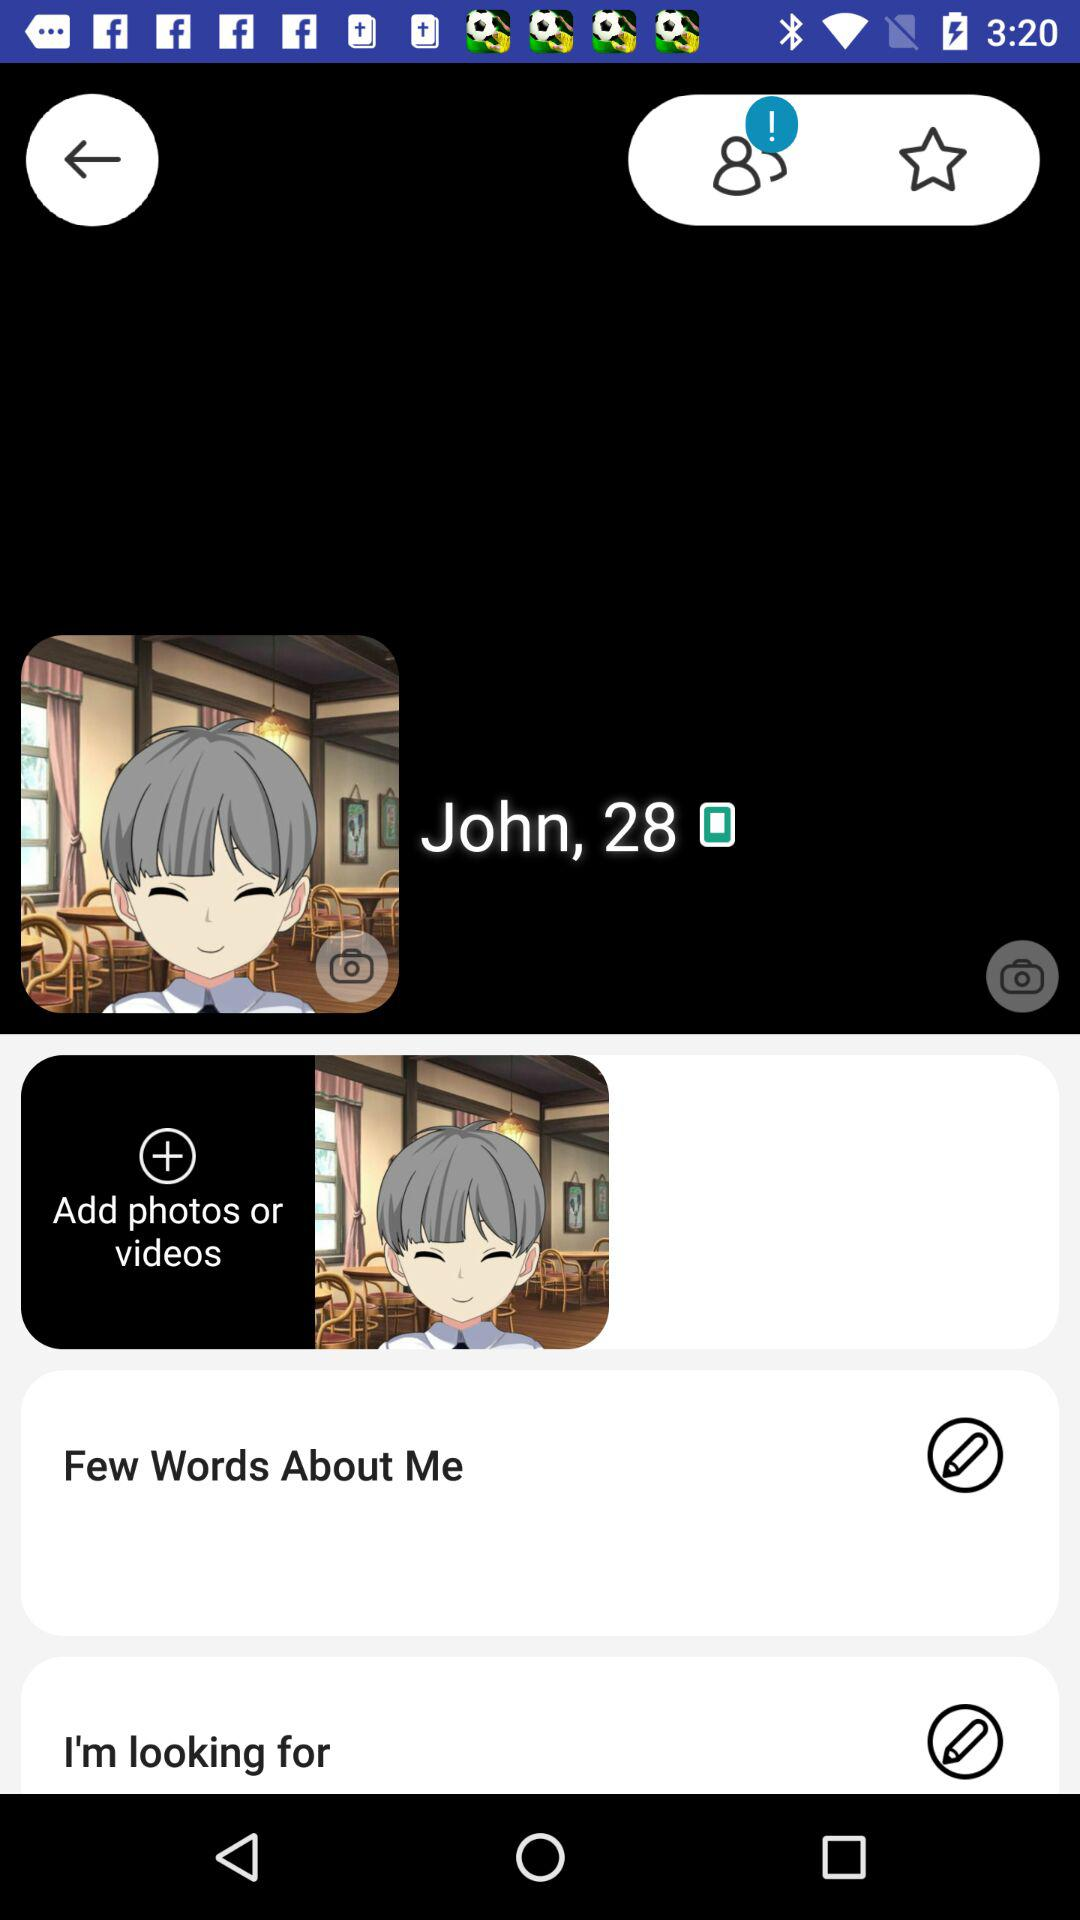How many requests are pending?
When the provided information is insufficient, respond with <no answer>. <no answer> 